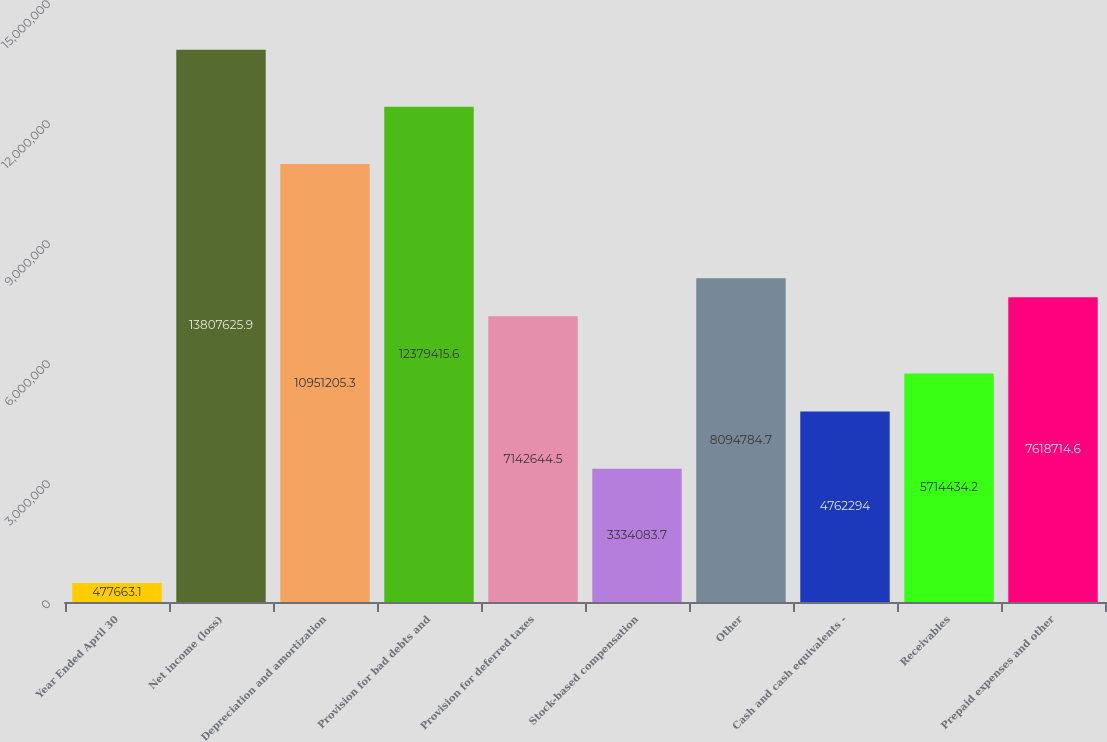<chart> <loc_0><loc_0><loc_500><loc_500><bar_chart><fcel>Year Ended April 30<fcel>Net income (loss)<fcel>Depreciation and amortization<fcel>Provision for bad debts and<fcel>Provision for deferred taxes<fcel>Stock-based compensation<fcel>Other<fcel>Cash and cash equivalents -<fcel>Receivables<fcel>Prepaid expenses and other<nl><fcel>477663<fcel>1.38076e+07<fcel>1.09512e+07<fcel>1.23794e+07<fcel>7.14264e+06<fcel>3.33408e+06<fcel>8.09478e+06<fcel>4.76229e+06<fcel>5.71443e+06<fcel>7.61871e+06<nl></chart> 